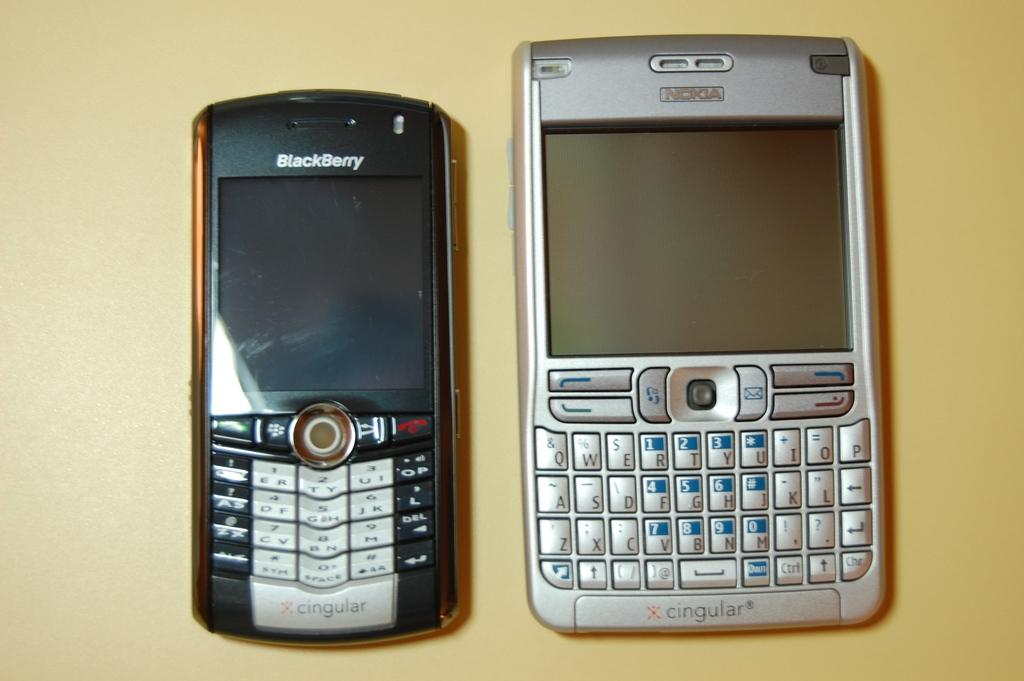<image>
Provide a brief description of the given image. two xcingular blackberry phones laying next to each other on a yellow counter 